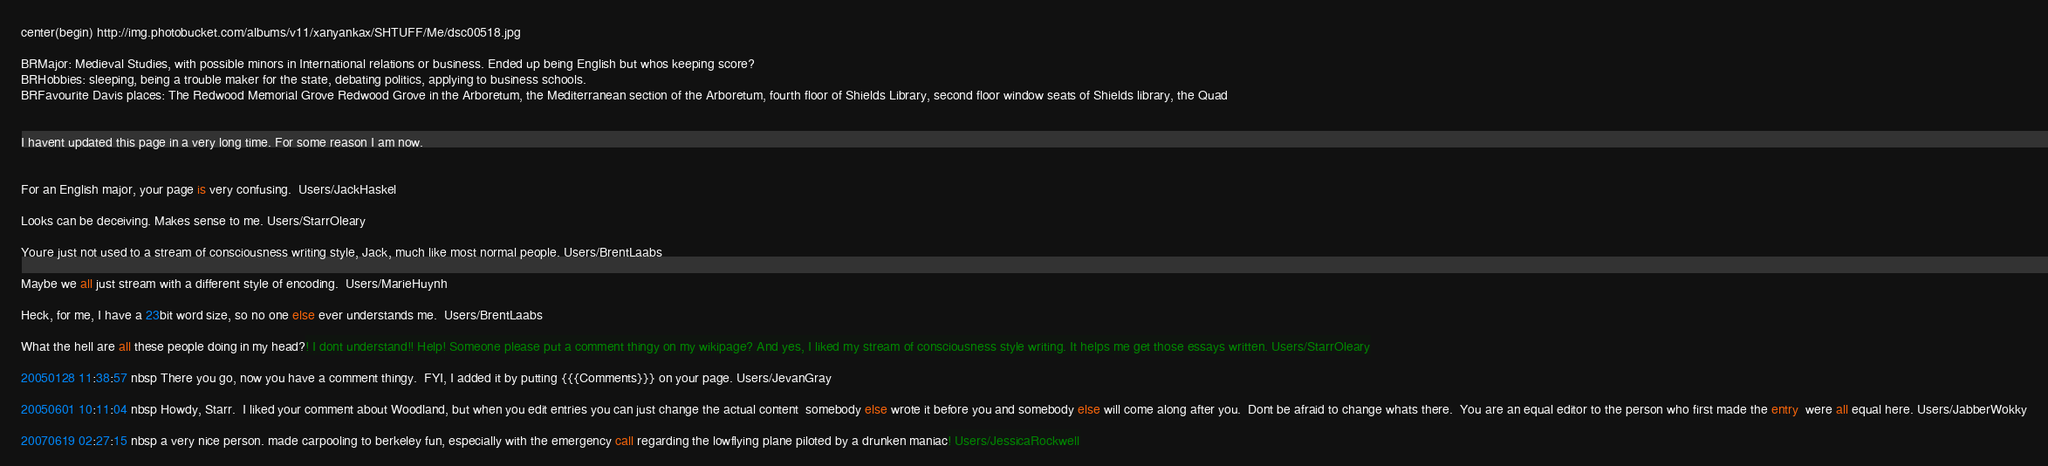Convert code to text. <code><loc_0><loc_0><loc_500><loc_500><_FORTRAN_>center(begin) http://img.photobucket.com/albums/v11/xanyankax/SHTUFF/Me/dsc00518.jpg

BRMajor: Medieval Studies, with possible minors in International relations or business. Ended up being English but whos keeping score?
BRHobbies: sleeping, being a trouble maker for the state, debating politics, applying to business schools.
BRFavourite Davis places: The Redwood Memorial Grove Redwood Grove in the Arboretum, the Mediterranean section of the Arboretum, fourth floor of Shields Library, second floor window seats of Shields library, the Quad


I havent updated this page in a very long time. For some reason I am now.


For an English major, your page is very confusing.  Users/JackHaskel

Looks can be deceiving. Makes sense to me. Users/StarrOleary

Youre just not used to a stream of consciousness writing style, Jack, much like most normal people. Users/BrentLaabs

Maybe we all just stream with a different style of encoding.  Users/MarieHuynh

Heck, for me, I have a 23bit word size, so no one else ever understands me.  Users/BrentLaabs

What the hell are all these people doing in my head?! I dont understand!! Help! Someone please put a comment thingy on my wikipage? And yes, I liked my stream of consciousness style writing. It helps me get those essays written. Users/StarrOleary

20050128 11:38:57 nbsp There you go, now you have a comment thingy.  FYI, I added it by putting {{{Comments}}} on your page. Users/JevanGray

20050601 10:11:04 nbsp Howdy, Starr.  I liked your comment about Woodland, but when you edit entries you can just change the actual content  somebody else wrote it before you and somebody else will come along after you.  Dont be afraid to change whats there.  You are an equal editor to the person who first made the entry  were all equal here. Users/JabberWokky

20070619 02:27:15 nbsp a very nice person. made carpooling to berkeley fun, especially with the emergency call regarding the lowflying plane piloted by a drunken maniac! Users/JessicaRockwell
</code> 